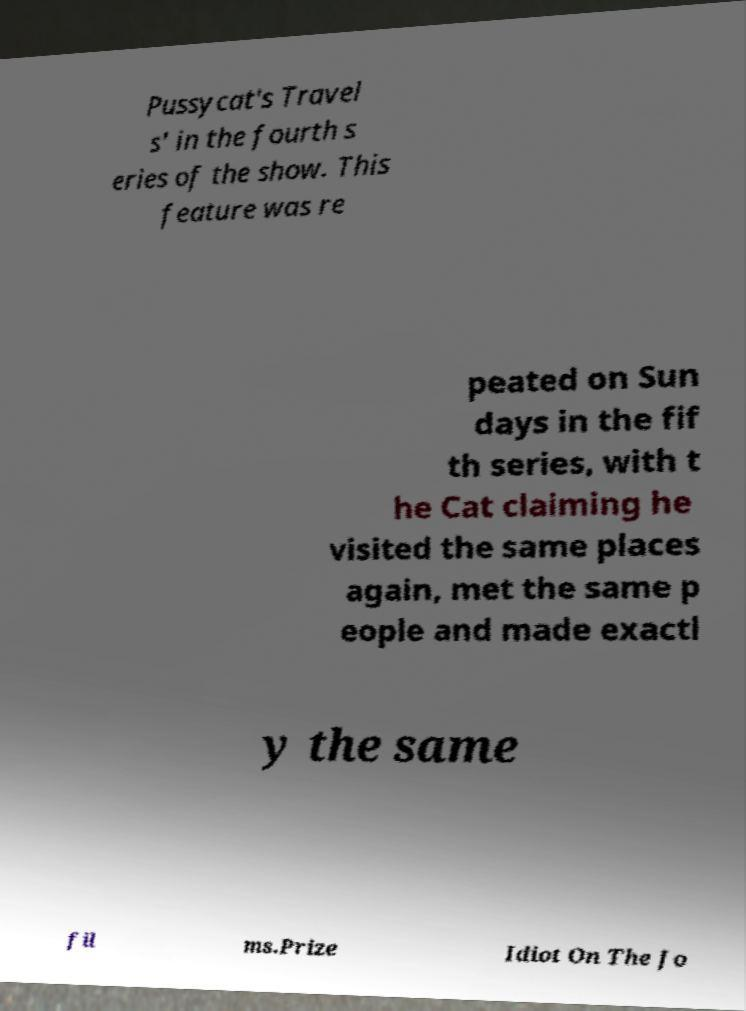Please read and relay the text visible in this image. What does it say? Pussycat's Travel s' in the fourth s eries of the show. This feature was re peated on Sun days in the fif th series, with t he Cat claiming he visited the same places again, met the same p eople and made exactl y the same fil ms.Prize Idiot On The Jo 